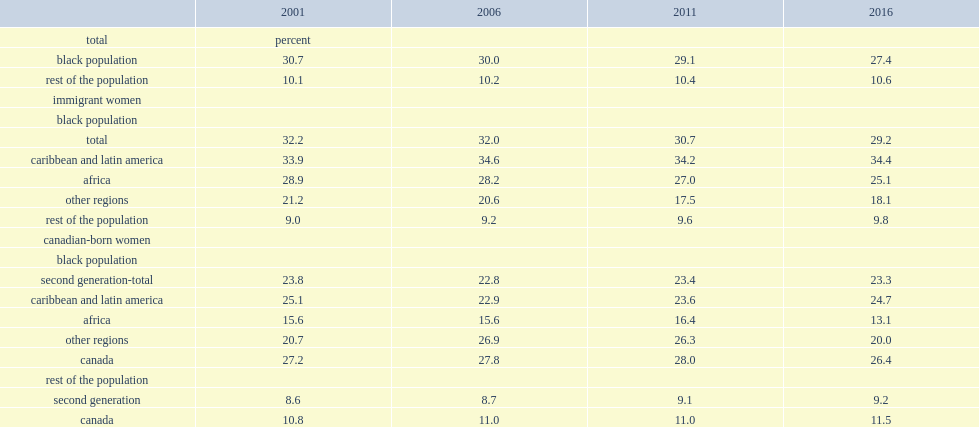Which population has more women aged 25 to 59 who were lone parents? black immigrants or the rest of the canadian population? Black population. How many percent of black immigrant women aged 25 to 59 in 2016 were lone parents? 29.2. Among black immigrant women aged 25 to 59 in 2016, how many percent of other immigrant women were lone parents? 9.8. Which region of origion of the immigrants has the highest proportion of lone mothers among black immigrant women aged 25 to 59 in 2016? Caribbean and latin america. 